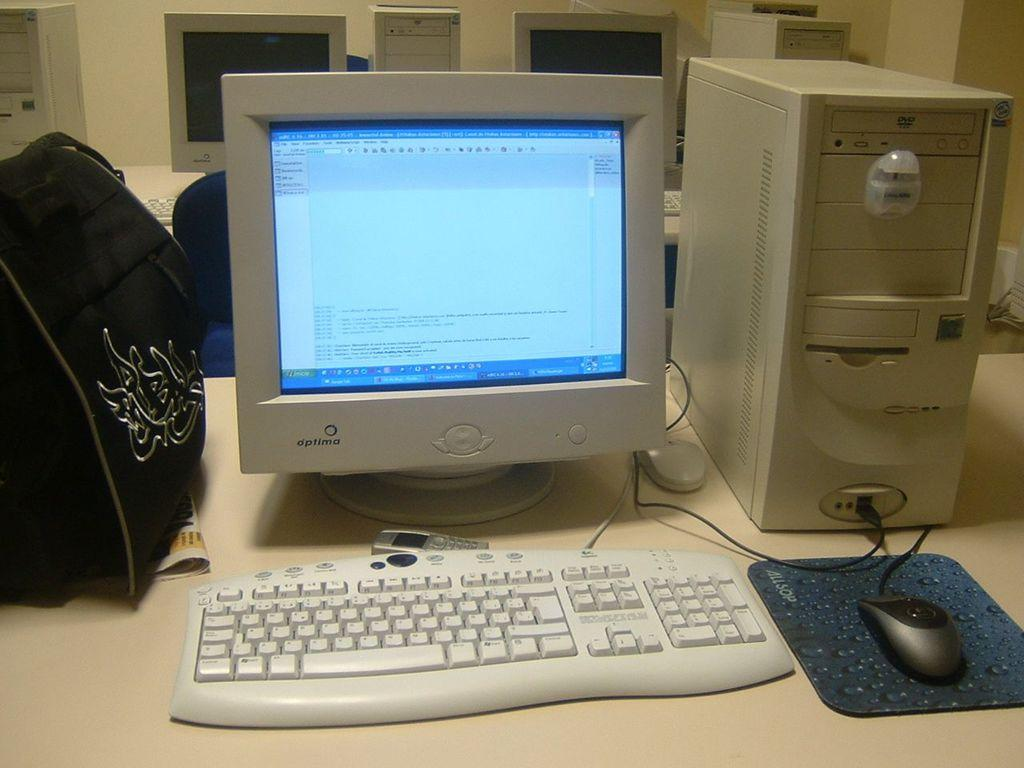<image>
Create a compact narrative representing the image presented. An Optima computer and it's keyboard and monitor are on a desk. 